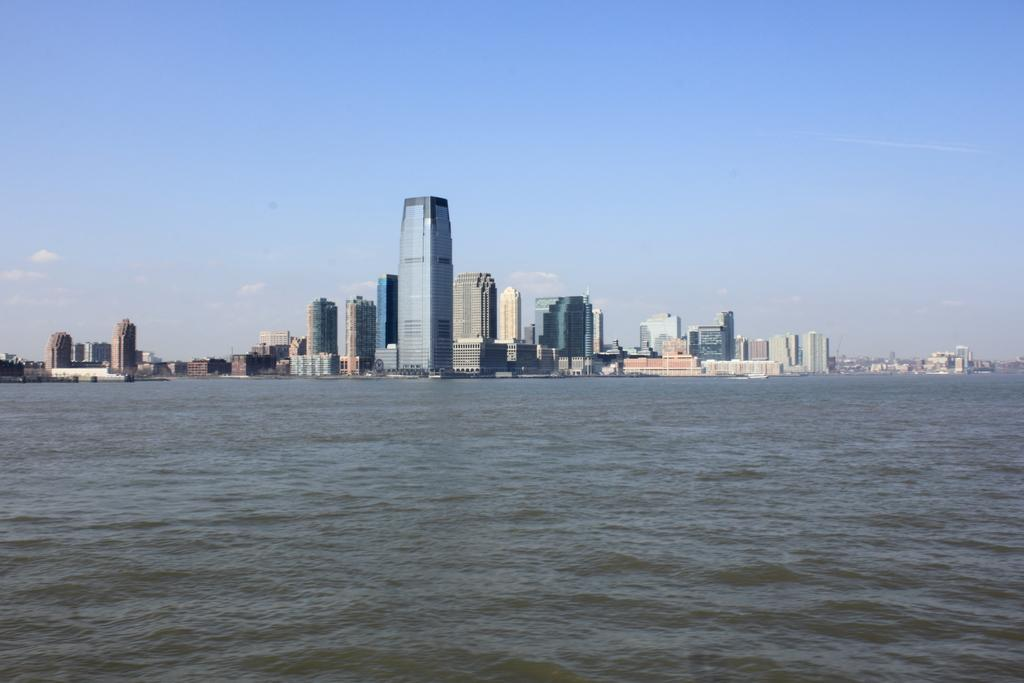What type of structures can be seen in the background of the image? There are buildings in the background of the image. What is visible in the sky in the image? The sky is visible in the background of the image. What is present at the bottom of the image? There is water at the bottom of the image. Can you see a toy rabbit playing near the water at the bottom of the image? There is no toy rabbit present in the image. What type of structure is visible in the water at the bottom of the image? There is no structure visible in the water at the bottom of the image; only water is present. 